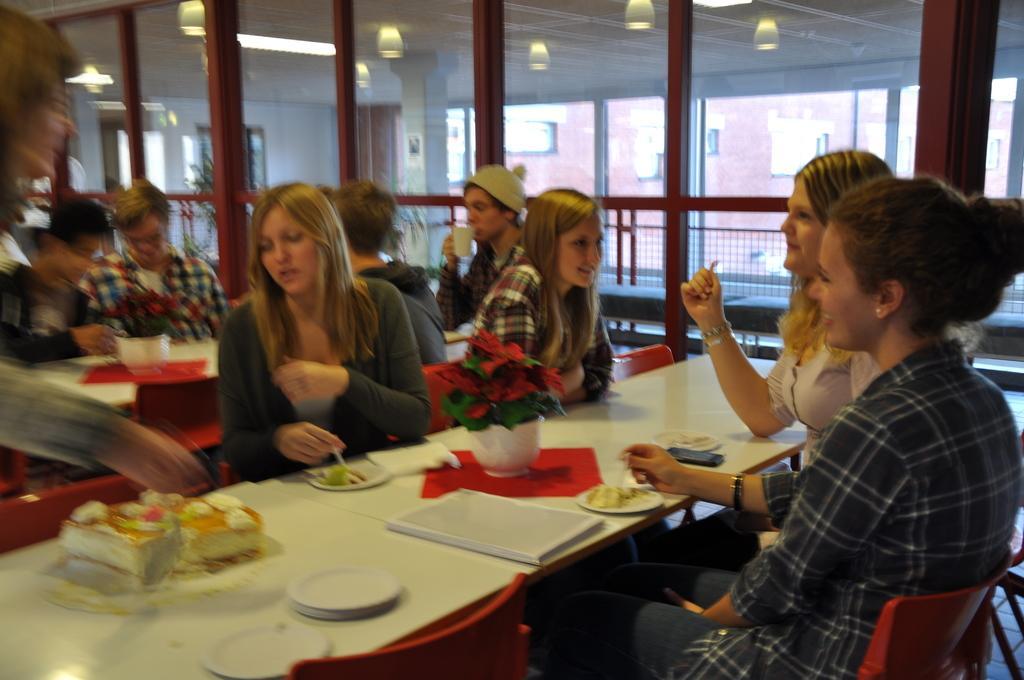Could you give a brief overview of what you see in this image? In the there are few woman sat on chairs on either sides of table,the table had cake,plates,bowls on it and back side of them there is group of men sat in similar way like them. it seems to be in a hotel. 